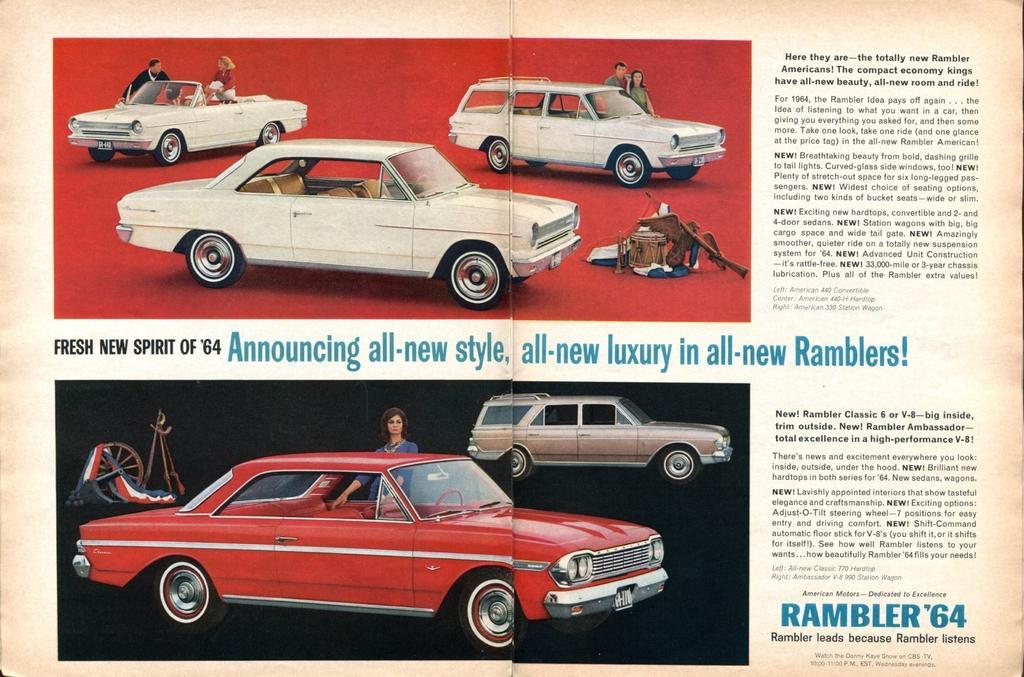Please provide a concise description of this image. In this image, we can see a magazine. In this picture, we can see few vehicles, people and some information. 